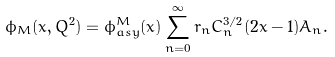<formula> <loc_0><loc_0><loc_500><loc_500>\phi _ { M } ( x , Q ^ { 2 } ) = \phi _ { a s y } ^ { M } ( x ) \sum ^ { \infty } _ { n = 0 } r _ { n } C _ { n } ^ { 3 / 2 } ( 2 x - 1 ) A _ { n } .</formula> 